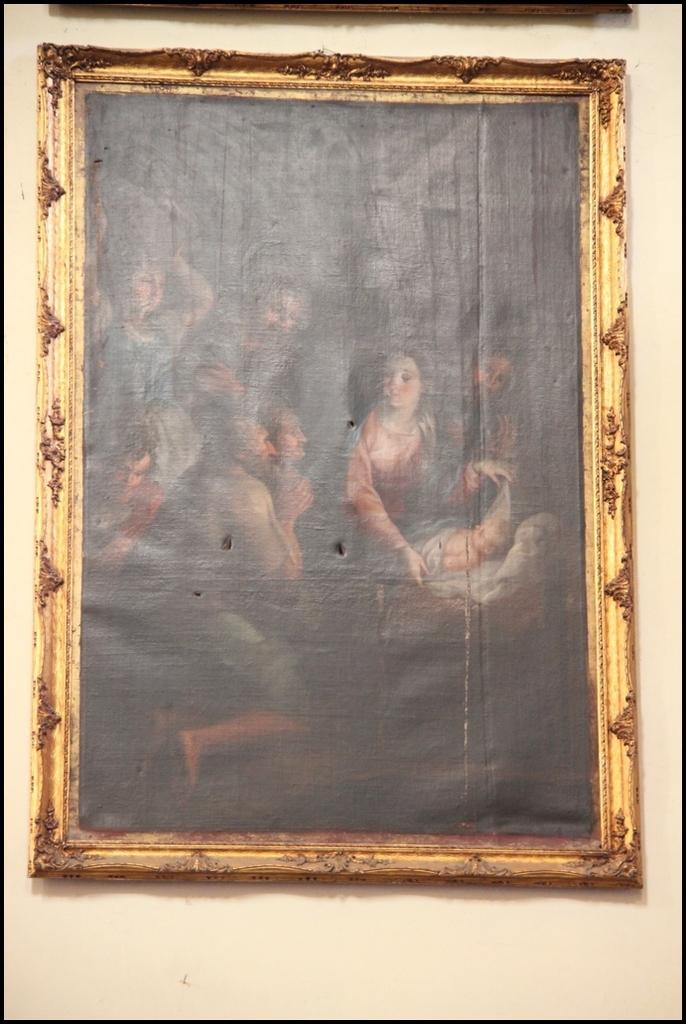What type of image is displayed in the photo frame? The image is a photograph in a photo frame. Who is present in the photograph? There is a woman in the photograph. Where are the men located in the photograph? The men are on the left side of the photograph. What type of cent can be seen on the woman's apparel in the photograph? There is no cent visible on the woman's apparel in the photograph. How many boots are worn by the men on the left side of the photograph? There is no information about boots or footwear worn by the men in the photograph. 